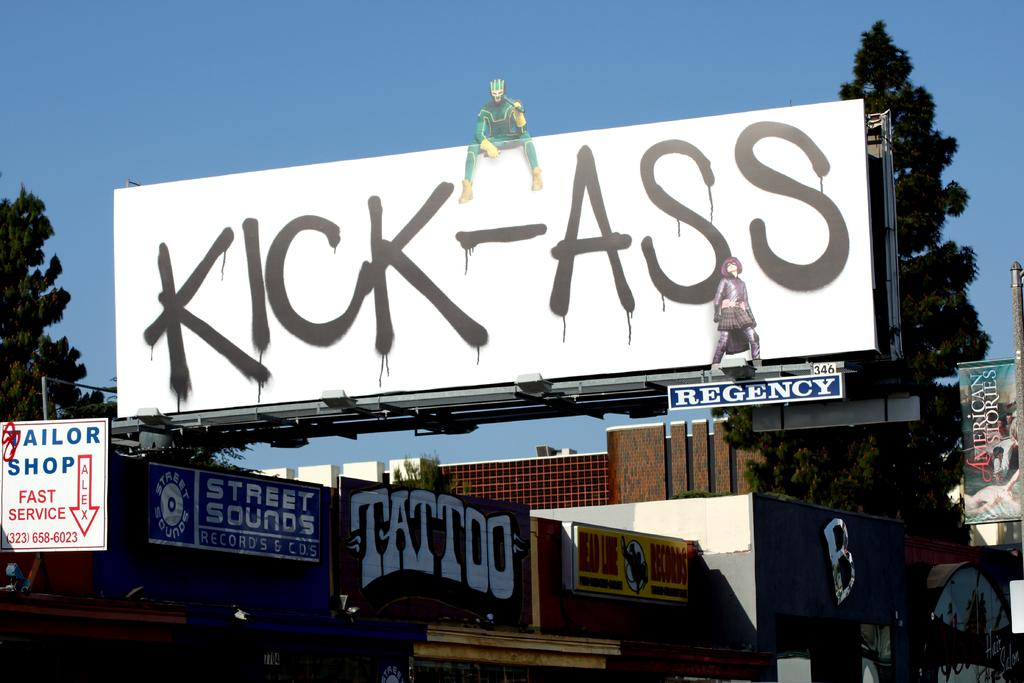Provide a one-sentence caption for the provided image. Large white billboard with black letters that say "Kick-Ass". 